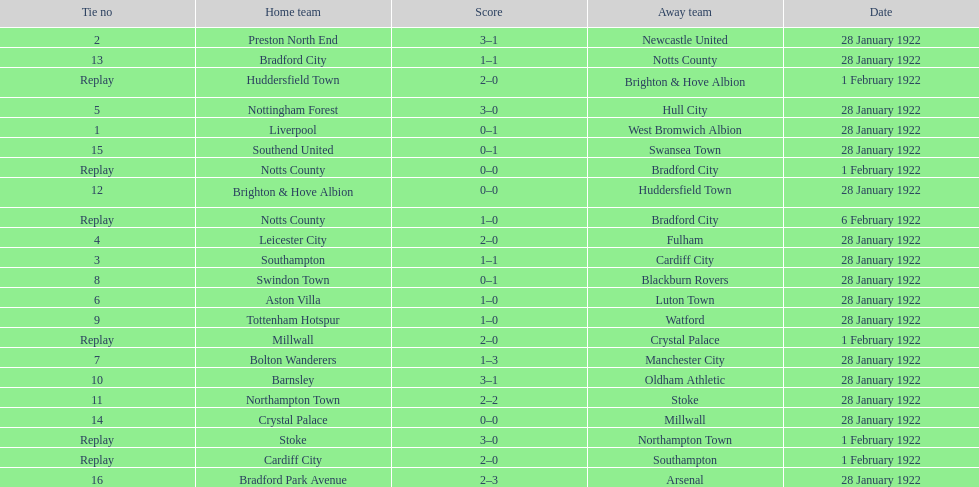How many games had four total points scored or more? 5. 